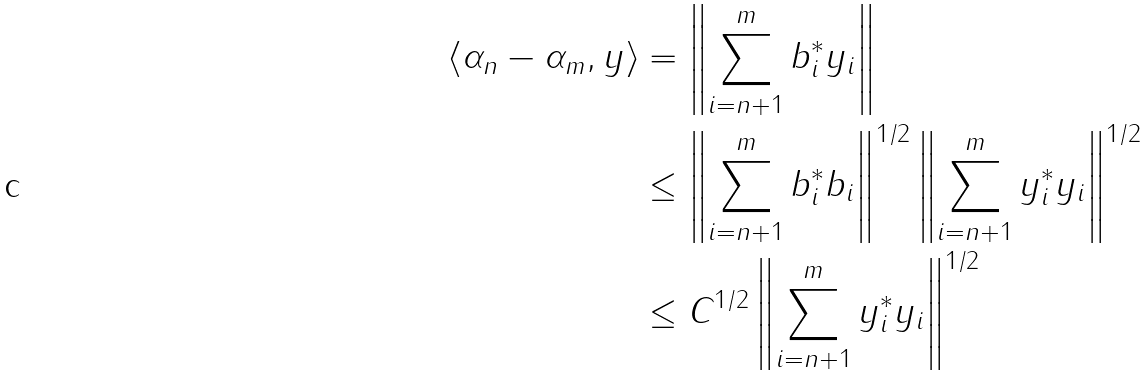Convert formula to latex. <formula><loc_0><loc_0><loc_500><loc_500>\| \langle \alpha _ { n } - \alpha _ { m } , y \rangle \| & = \left \| \sum _ { i = n + 1 } ^ { m } b _ { i } ^ { * } y _ { i } \right \| \\ & \leq \left \| \sum _ { i = n + 1 } ^ { m } b _ { i } ^ { * } b _ { i } \right \| ^ { 1 / 2 } \left \| \sum _ { i = n + 1 } ^ { m } y _ { i } ^ { * } y _ { i } \right \| ^ { 1 / 2 } \\ & \leq C ^ { 1 / 2 } \left \| \sum _ { i = n + 1 } ^ { m } y _ { i } ^ { * } y _ { i } \right \| ^ { 1 / 2 }</formula> 